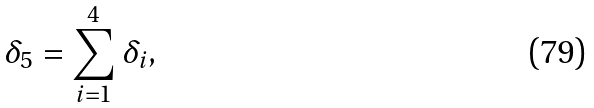<formula> <loc_0><loc_0><loc_500><loc_500>\delta _ { 5 } = \sum _ { i = 1 } ^ { 4 } \delta _ { i } ,</formula> 